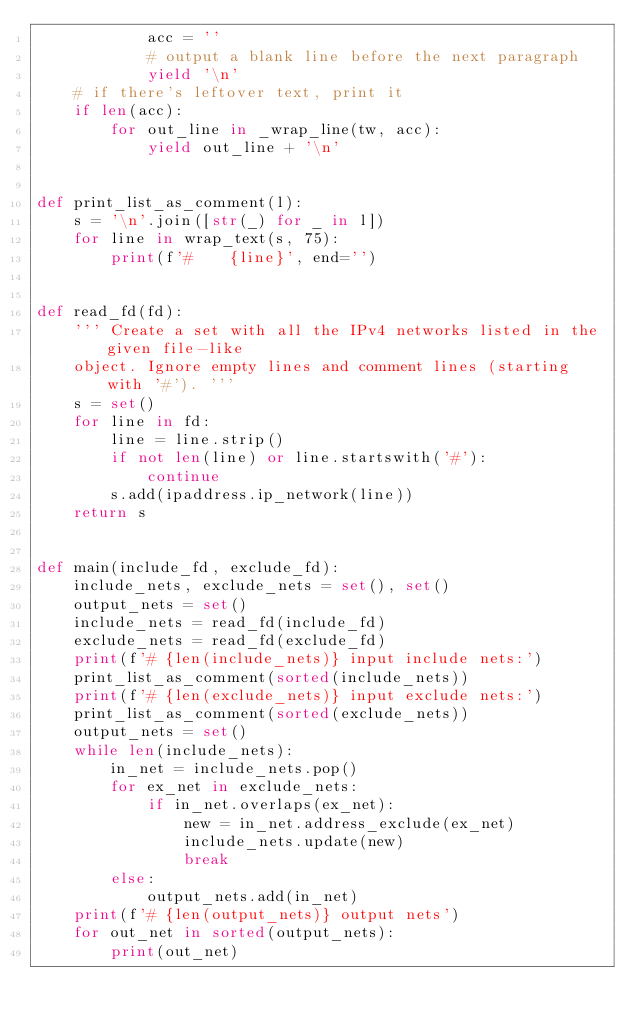<code> <loc_0><loc_0><loc_500><loc_500><_Python_>            acc = ''
            # output a blank line before the next paragraph
            yield '\n'
    # if there's leftover text, print it
    if len(acc):
        for out_line in _wrap_line(tw, acc):
            yield out_line + '\n'


def print_list_as_comment(l):
    s = '\n'.join([str(_) for _ in l])
    for line in wrap_text(s, 75):
        print(f'#    {line}', end='')


def read_fd(fd):
    ''' Create a set with all the IPv4 networks listed in the given file-like
    object. Ignore empty lines and comment lines (starting with '#'). '''
    s = set()
    for line in fd:
        line = line.strip()
        if not len(line) or line.startswith('#'):
            continue
        s.add(ipaddress.ip_network(line))
    return s


def main(include_fd, exclude_fd):
    include_nets, exclude_nets = set(), set()
    output_nets = set()
    include_nets = read_fd(include_fd)
    exclude_nets = read_fd(exclude_fd)
    print(f'# {len(include_nets)} input include nets:')
    print_list_as_comment(sorted(include_nets))
    print(f'# {len(exclude_nets)} input exclude nets:')
    print_list_as_comment(sorted(exclude_nets))
    output_nets = set()
    while len(include_nets):
        in_net = include_nets.pop()
        for ex_net in exclude_nets:
            if in_net.overlaps(ex_net):
                new = in_net.address_exclude(ex_net)
                include_nets.update(new)
                break
        else:
            output_nets.add(in_net)
    print(f'# {len(output_nets)} output nets')
    for out_net in sorted(output_nets):
        print(out_net)</code> 